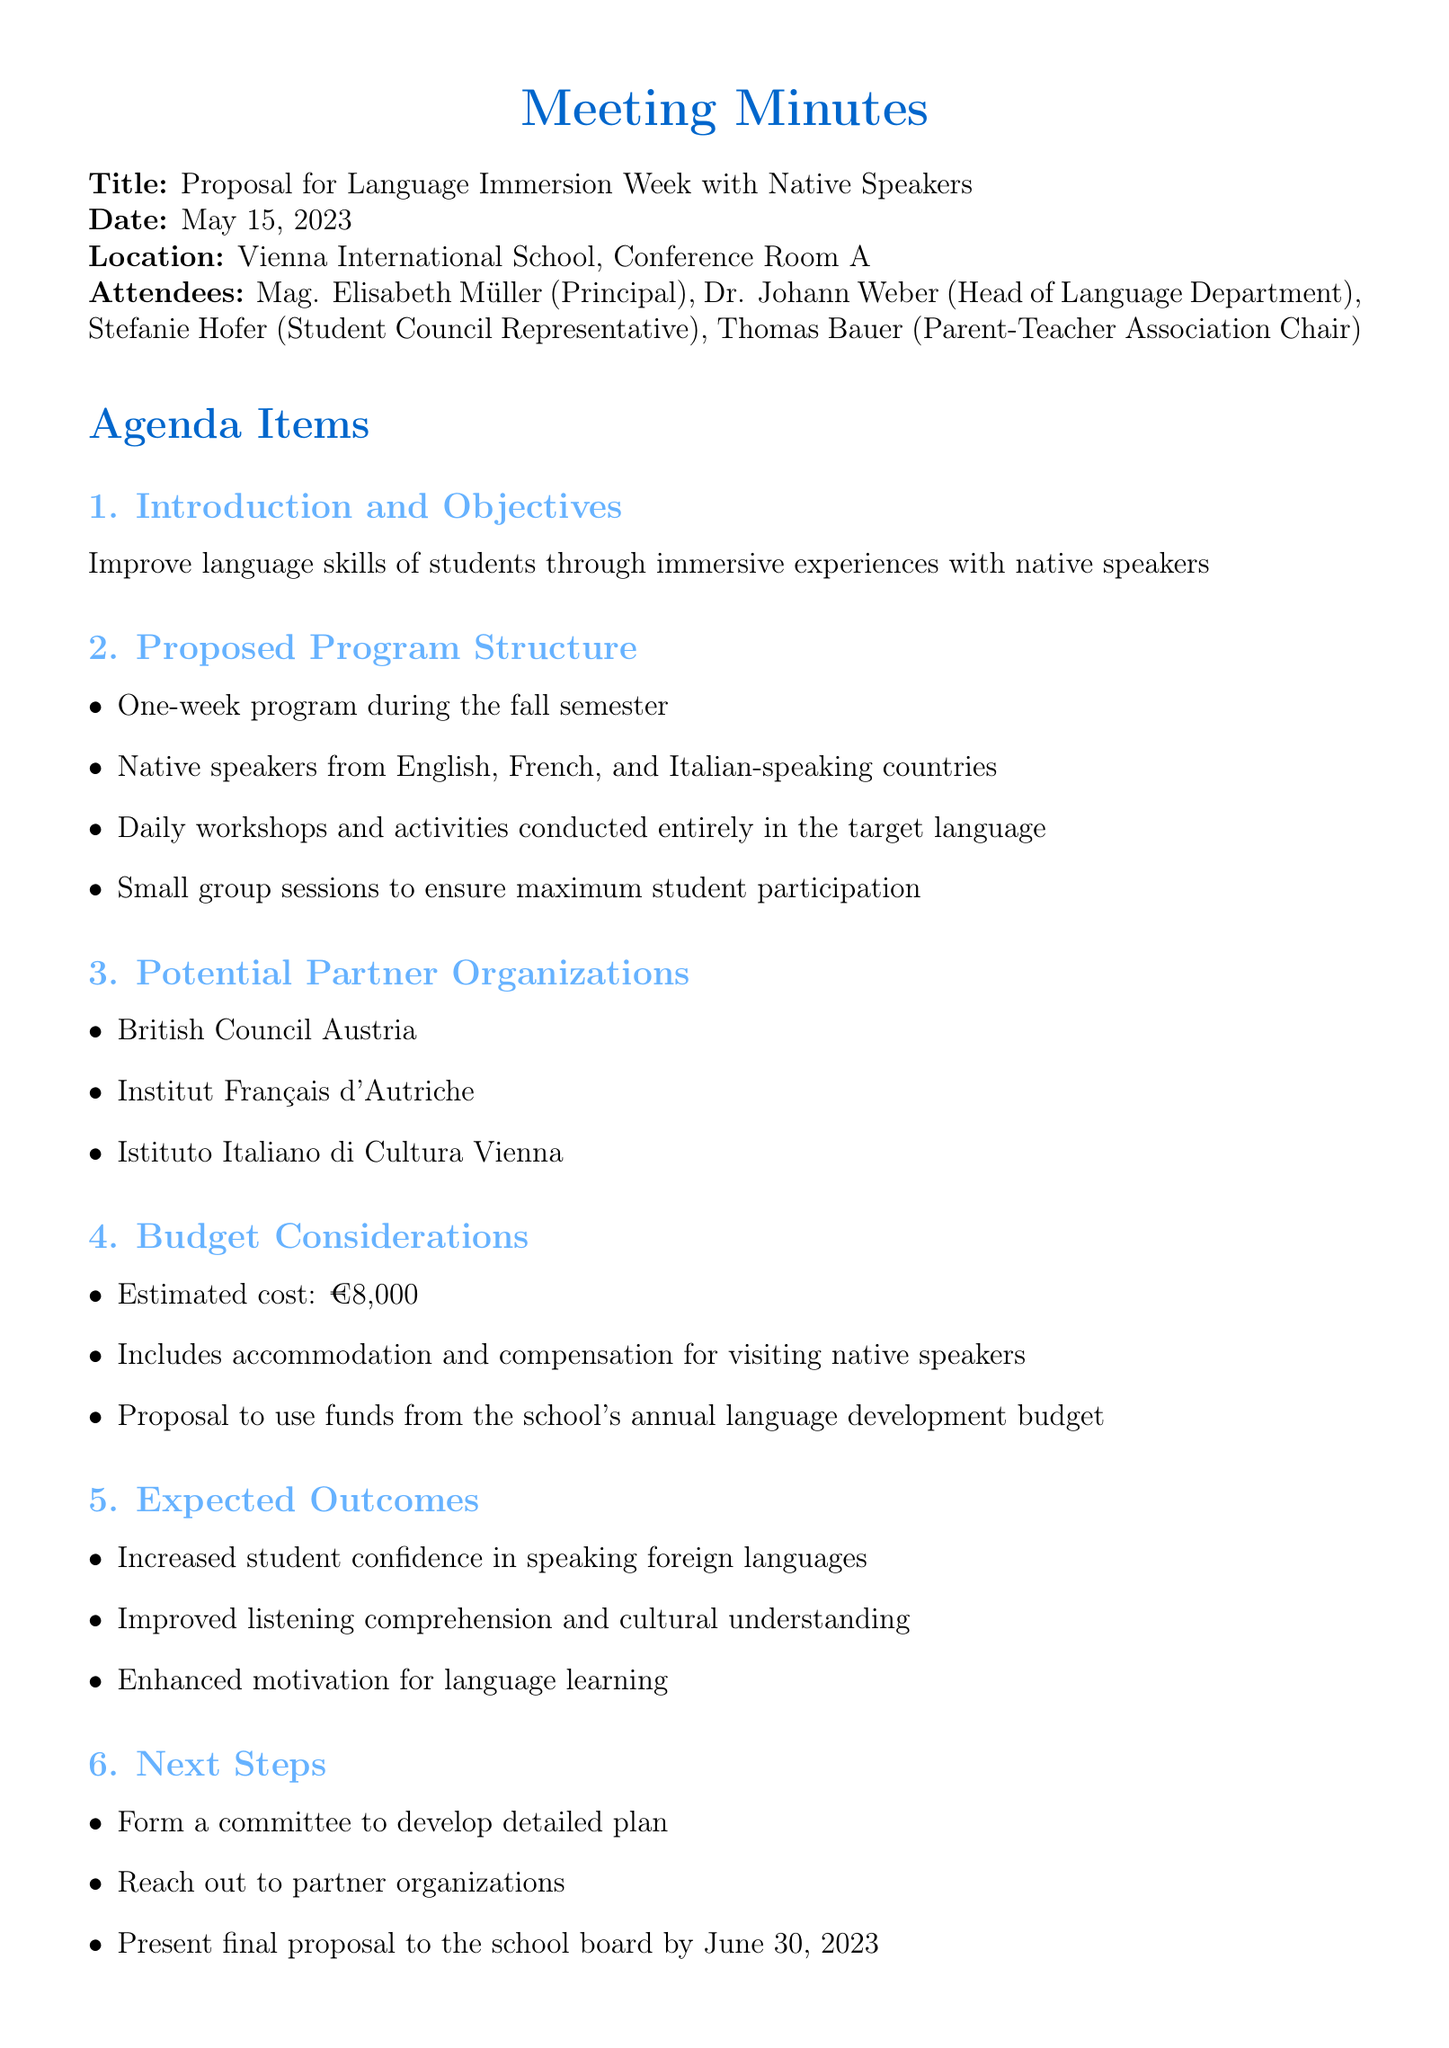what is the title of the meeting? The title is stated at the beginning of the document, indicating the focus of the meeting.
Answer: Proposal for Language Immersion Week with Native Speakers when did the meeting take place? The date of the meeting is explicitly mentioned in the document.
Answer: May 15, 2023 who is the Principal? The Principal is listed among the attendees of the meeting, providing their title and name.
Answer: Mag. Elisabeth Müller what is the estimated cost of the program? The budget considerations section specifies the estimated cost for the program.
Answer: €8,000 what are the expected outcomes of the language immersion week? The expected outcomes are summarized in a list within the document under a specific agenda item.
Answer: Increased student confidence in speaking foreign languages which organizations are proposed as partners? The potential partner organizations are clearly listed, showcasing the potential collaborators for the program.
Answer: British Council Austria what is one of the next steps mentioned in the meeting? The next steps are detailed in a list, indicating actions to be taken following the meeting.
Answer: Form a committee to develop detailed plan who is responsible for gathering student input on preferred activities? The action items section identifies responsibilities among attendees, specifying who will gather input.
Answer: Stefanie Hofer which languages will the native speakers represent? The program structure specifies which target languages will be emphasized by the visiting speakers.
Answer: English, French, and Italian 